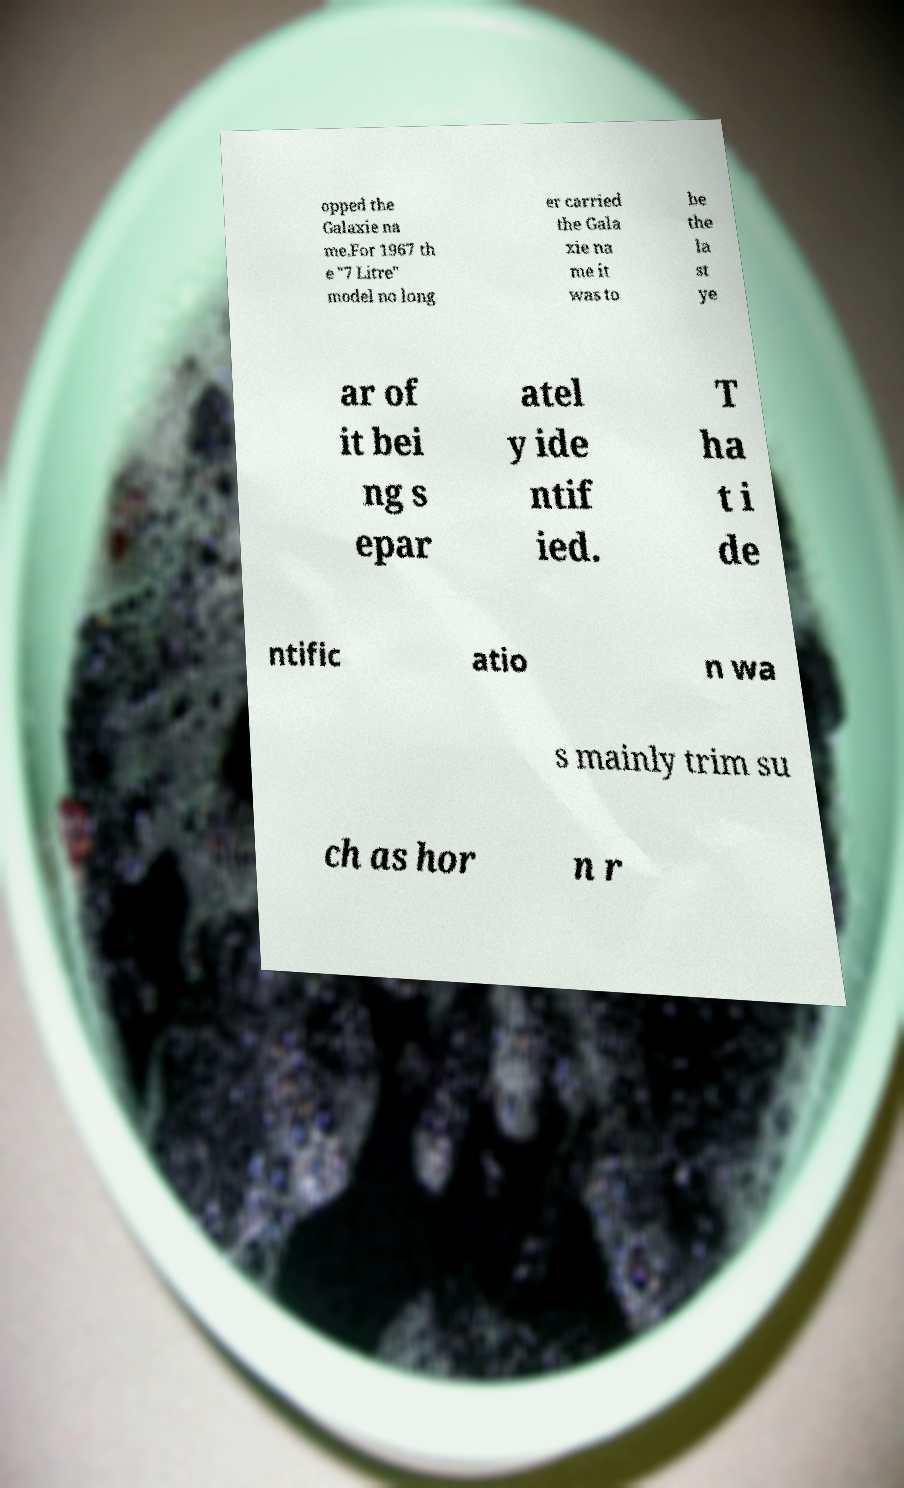Could you assist in decoding the text presented in this image and type it out clearly? opped the Galaxie na me.For 1967 th e "7 Litre" model no long er carried the Gala xie na me it was to be the la st ye ar of it bei ng s epar atel y ide ntif ied. T ha t i de ntific atio n wa s mainly trim su ch as hor n r 